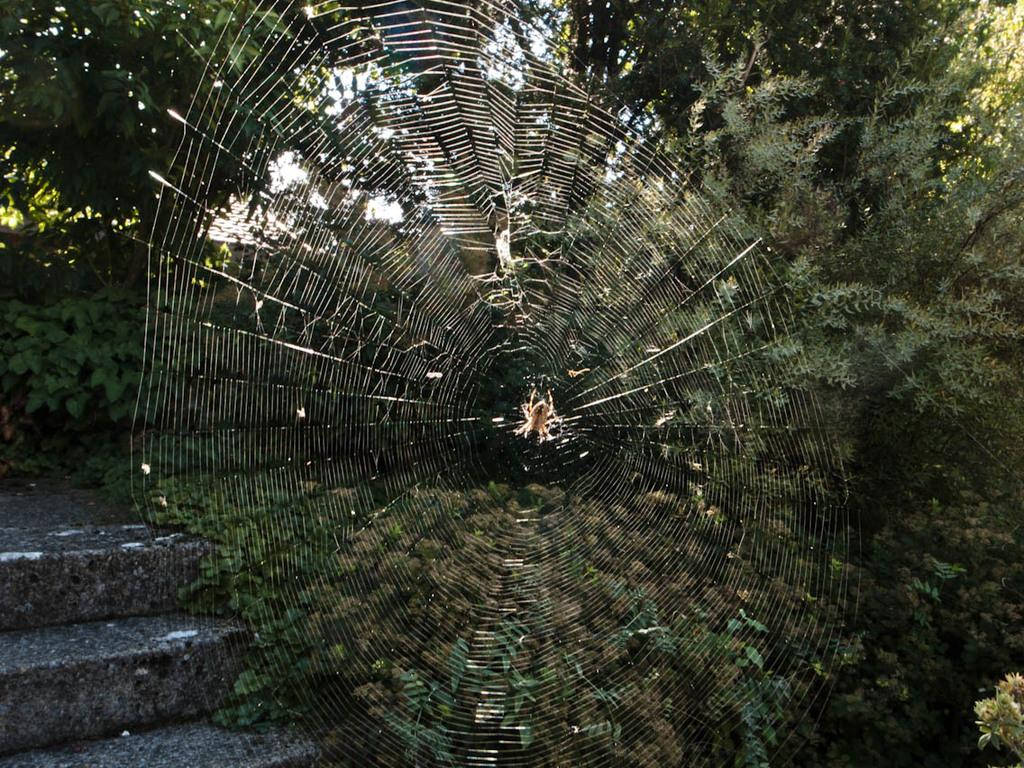What is the main subject of the image? There is a spider in the image. Where is the spider located in the image? The spider is in the middle of a spider web. What can be seen in the background of the image? There are trees in the background of the image. What type of shoe is hanging from the spider web in the image? There is no shoe present in the image; it only features a spider and a spider web. 